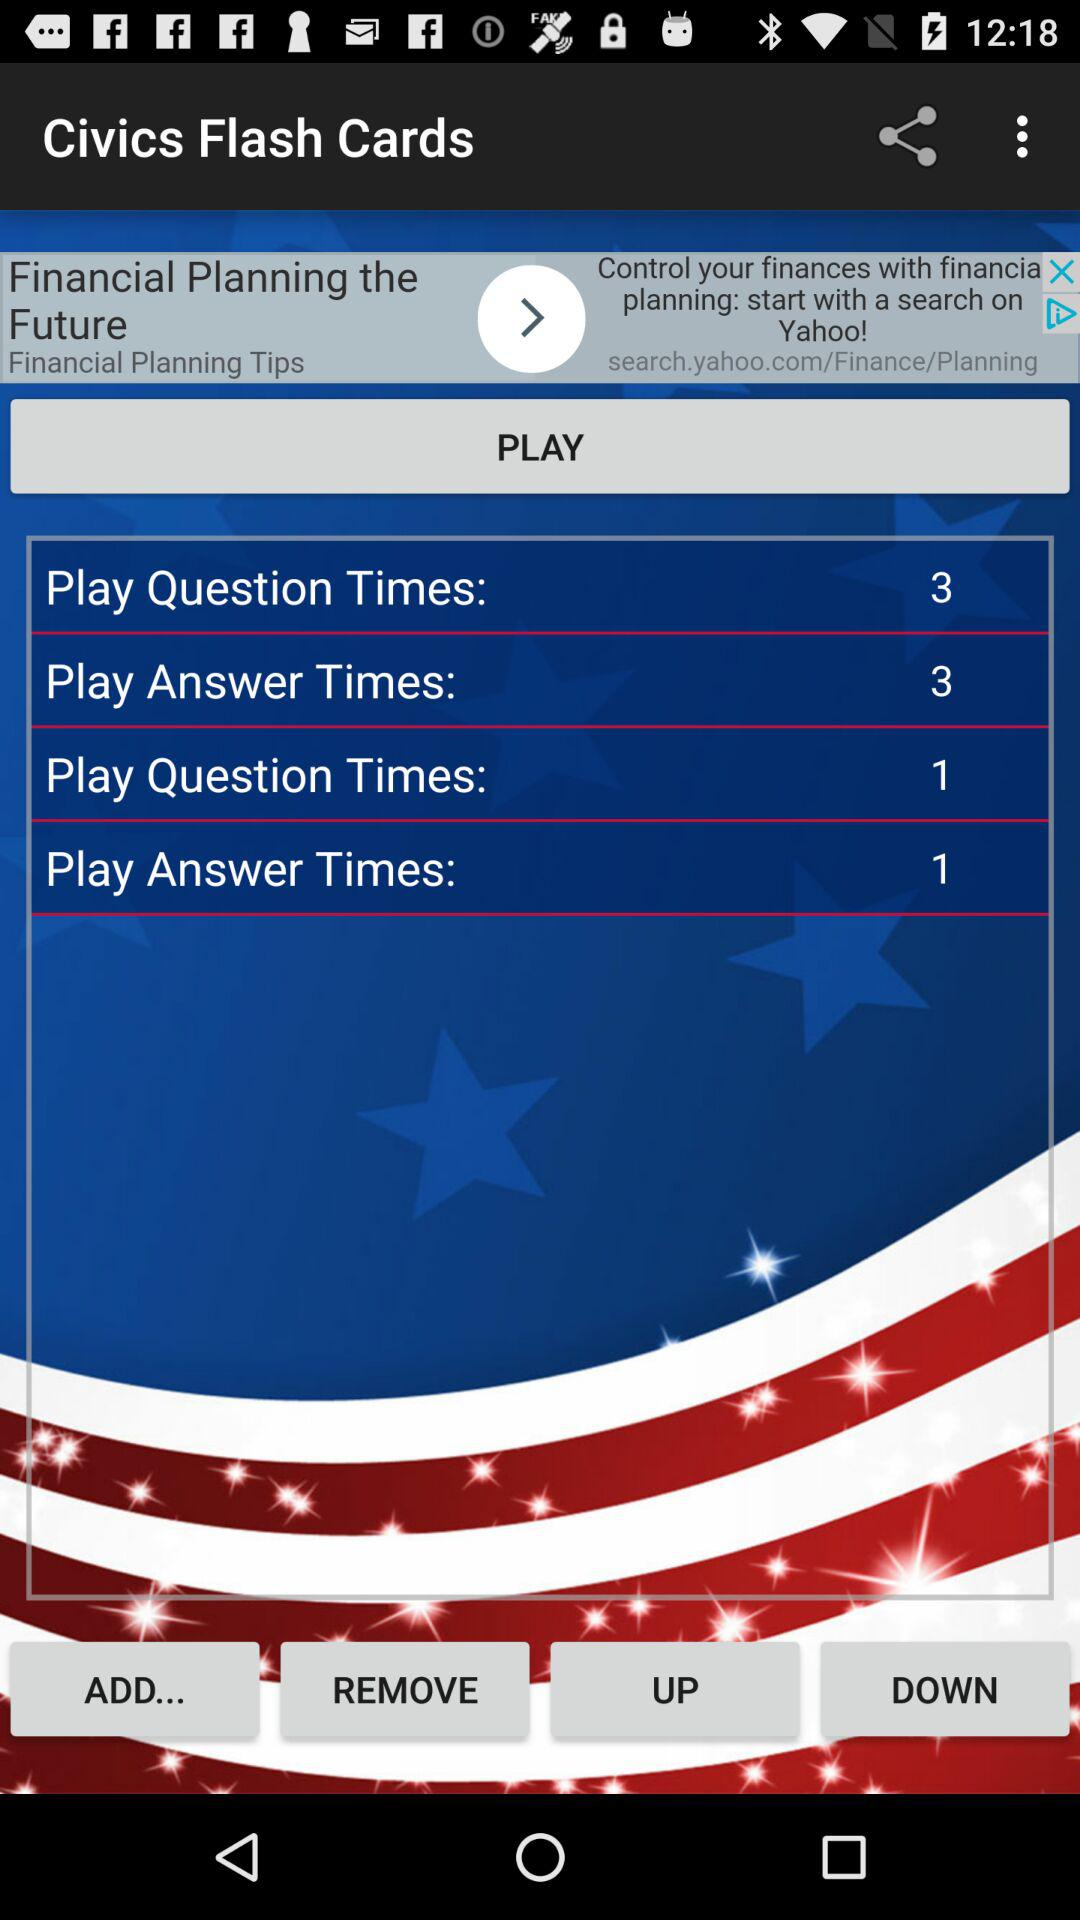What is the application name? The application name is "Civics Flash Cards". 